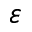<formula> <loc_0><loc_0><loc_500><loc_500>\varepsilon</formula> 